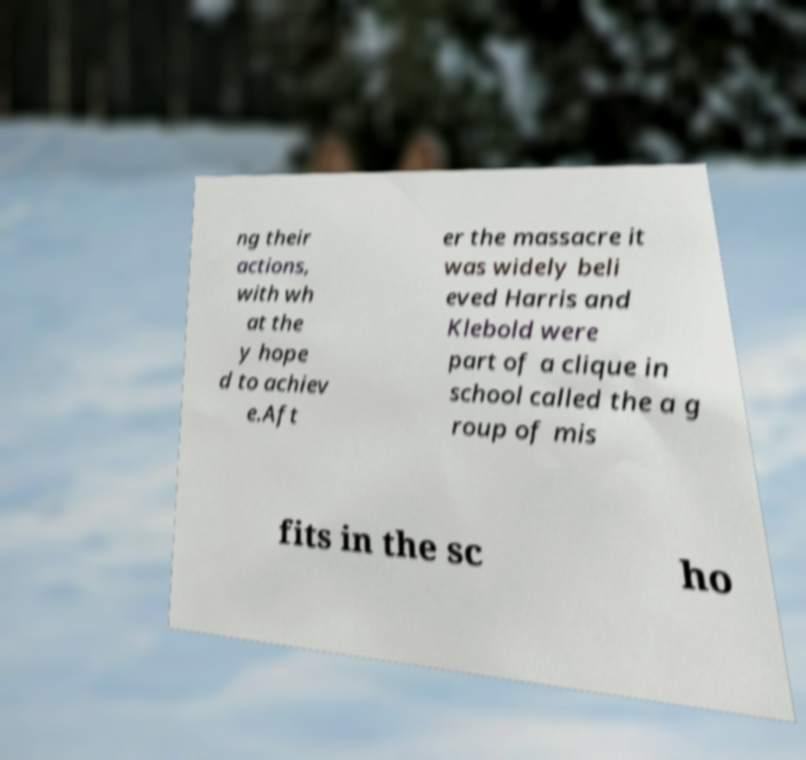For documentation purposes, I need the text within this image transcribed. Could you provide that? ng their actions, with wh at the y hope d to achiev e.Aft er the massacre it was widely beli eved Harris and Klebold were part of a clique in school called the a g roup of mis fits in the sc ho 